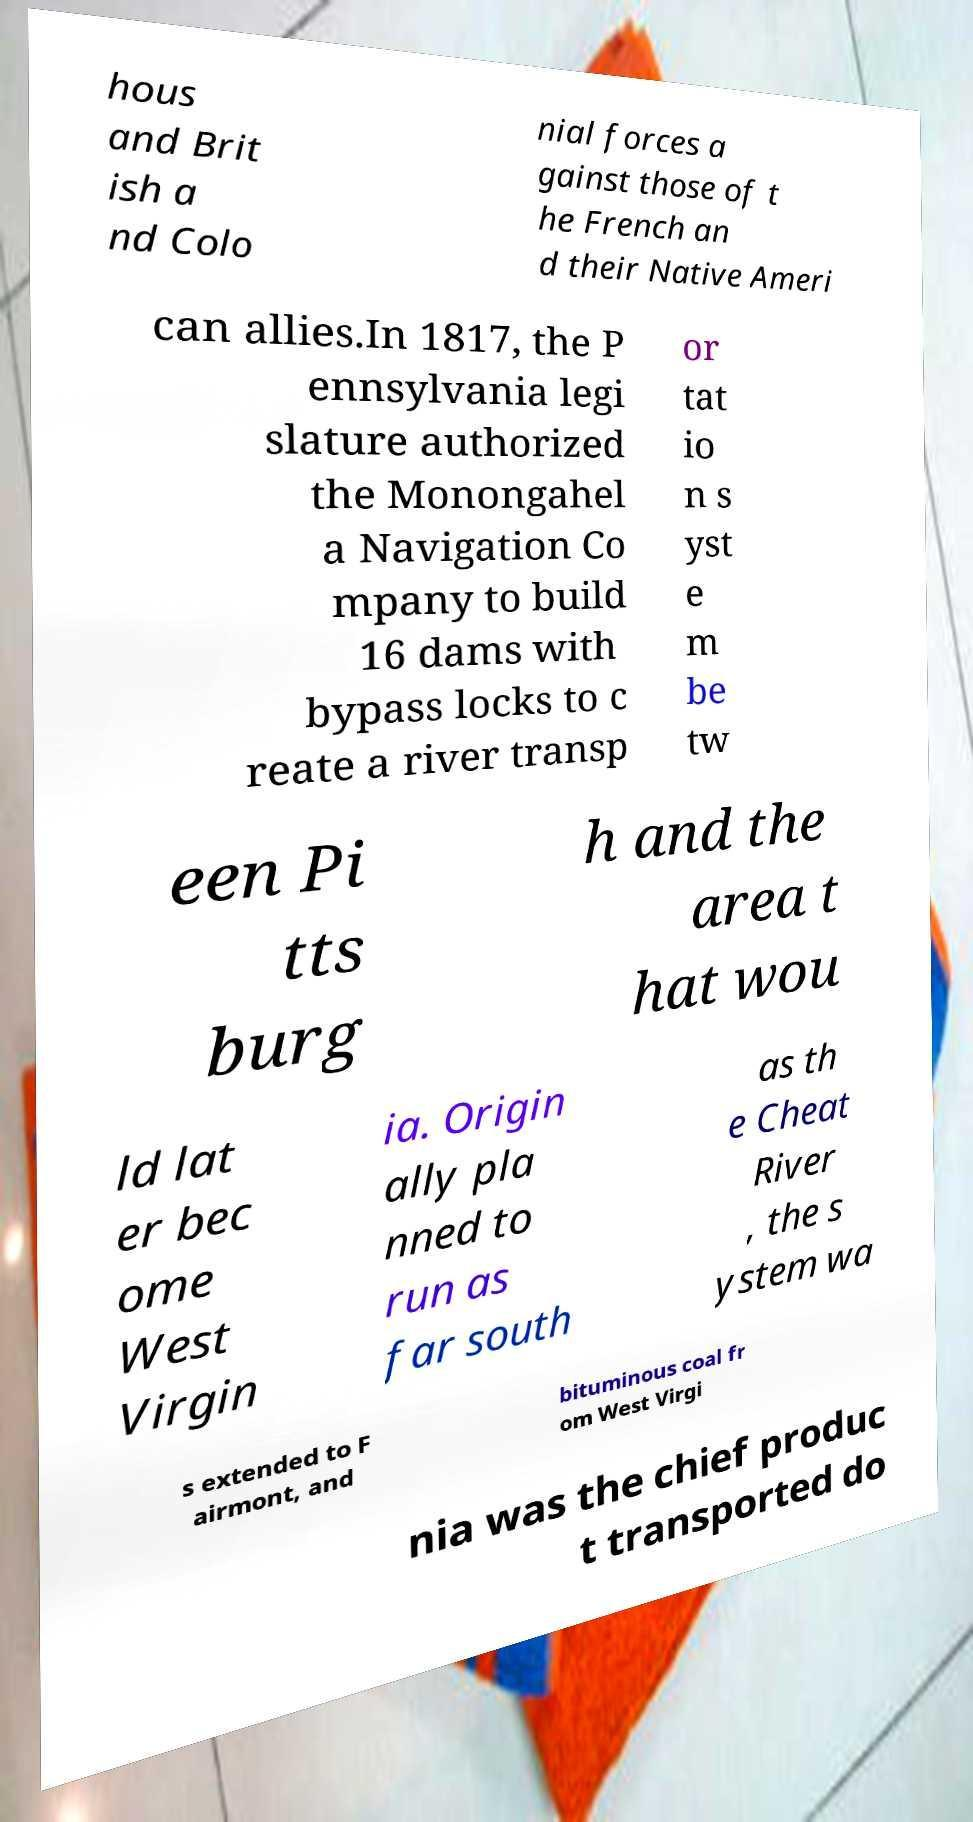Can you accurately transcribe the text from the provided image for me? hous and Brit ish a nd Colo nial forces a gainst those of t he French an d their Native Ameri can allies.In 1817, the P ennsylvania legi slature authorized the Monongahel a Navigation Co mpany to build 16 dams with bypass locks to c reate a river transp or tat io n s yst e m be tw een Pi tts burg h and the area t hat wou ld lat er bec ome West Virgin ia. Origin ally pla nned to run as far south as th e Cheat River , the s ystem wa s extended to F airmont, and bituminous coal fr om West Virgi nia was the chief produc t transported do 